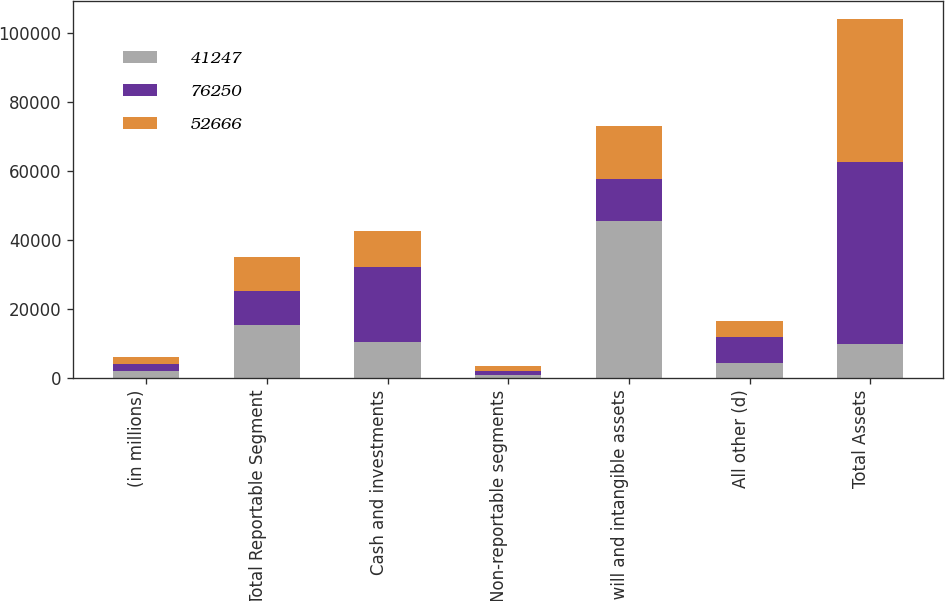<chart> <loc_0><loc_0><loc_500><loc_500><stacked_bar_chart><ecel><fcel>(in millions)<fcel>Total Reportable Segment<fcel>Cash and investments<fcel>Non-reportable segments<fcel>Goodwill and intangible assets<fcel>All other (d)<fcel>Total Assets<nl><fcel>41247<fcel>2017<fcel>15188<fcel>10493<fcel>740<fcel>45493<fcel>4336<fcel>9911<nl><fcel>76250<fcel>2016<fcel>10045<fcel>21722<fcel>1280<fcel>12222<fcel>7397<fcel>52666<nl><fcel>52666<fcel>2015<fcel>9777<fcel>10166<fcel>1267<fcel>15200<fcel>4837<fcel>41247<nl></chart> 